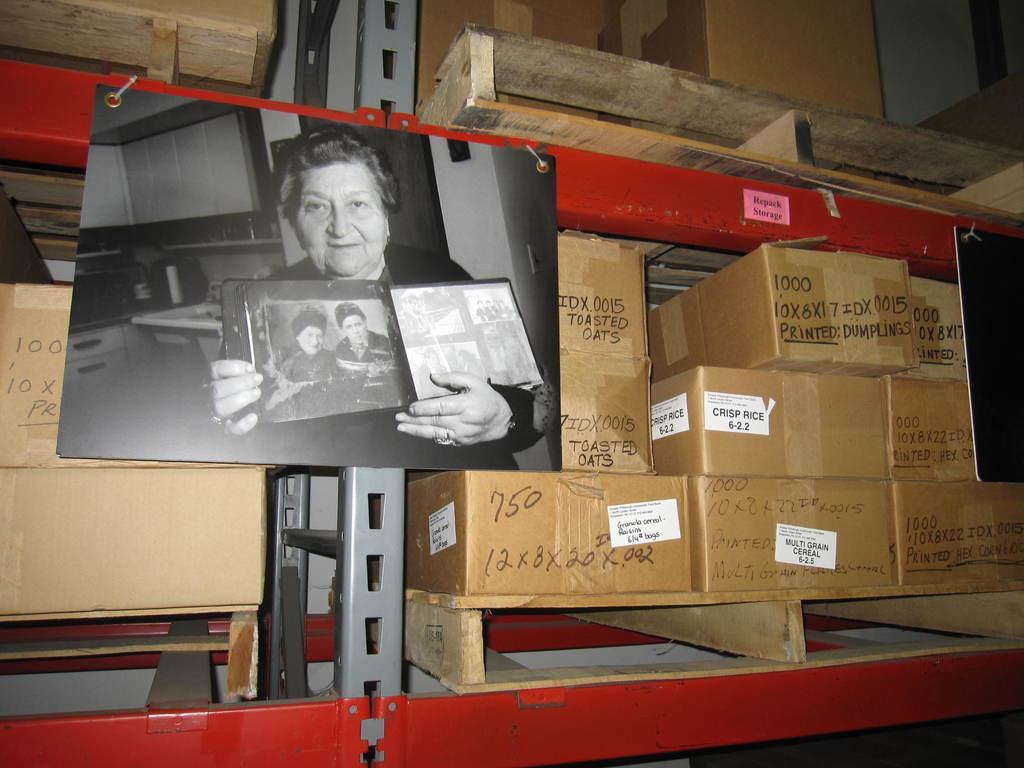In one or two sentences, can you explain what this image depicts? The picture consists of shelves, boxes and some wooden objects. In the center of the picture there is a photograph, in the photograph there is a woman holding a frame. 